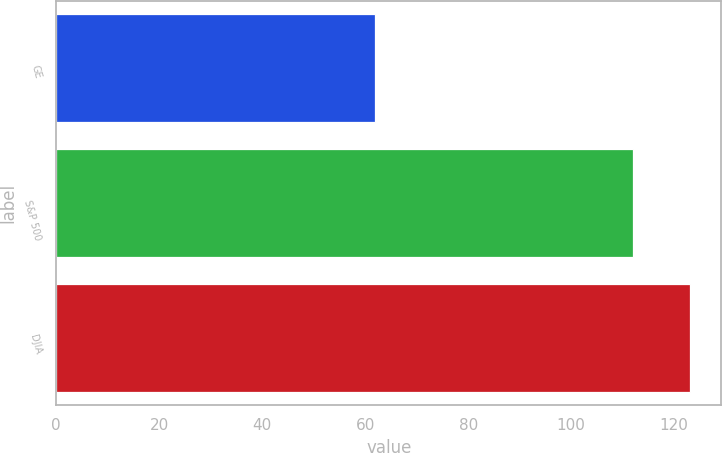Convert chart. <chart><loc_0><loc_0><loc_500><loc_500><bar_chart><fcel>GE<fcel>S&P 500<fcel>DJIA<nl><fcel>62<fcel>112<fcel>123<nl></chart> 